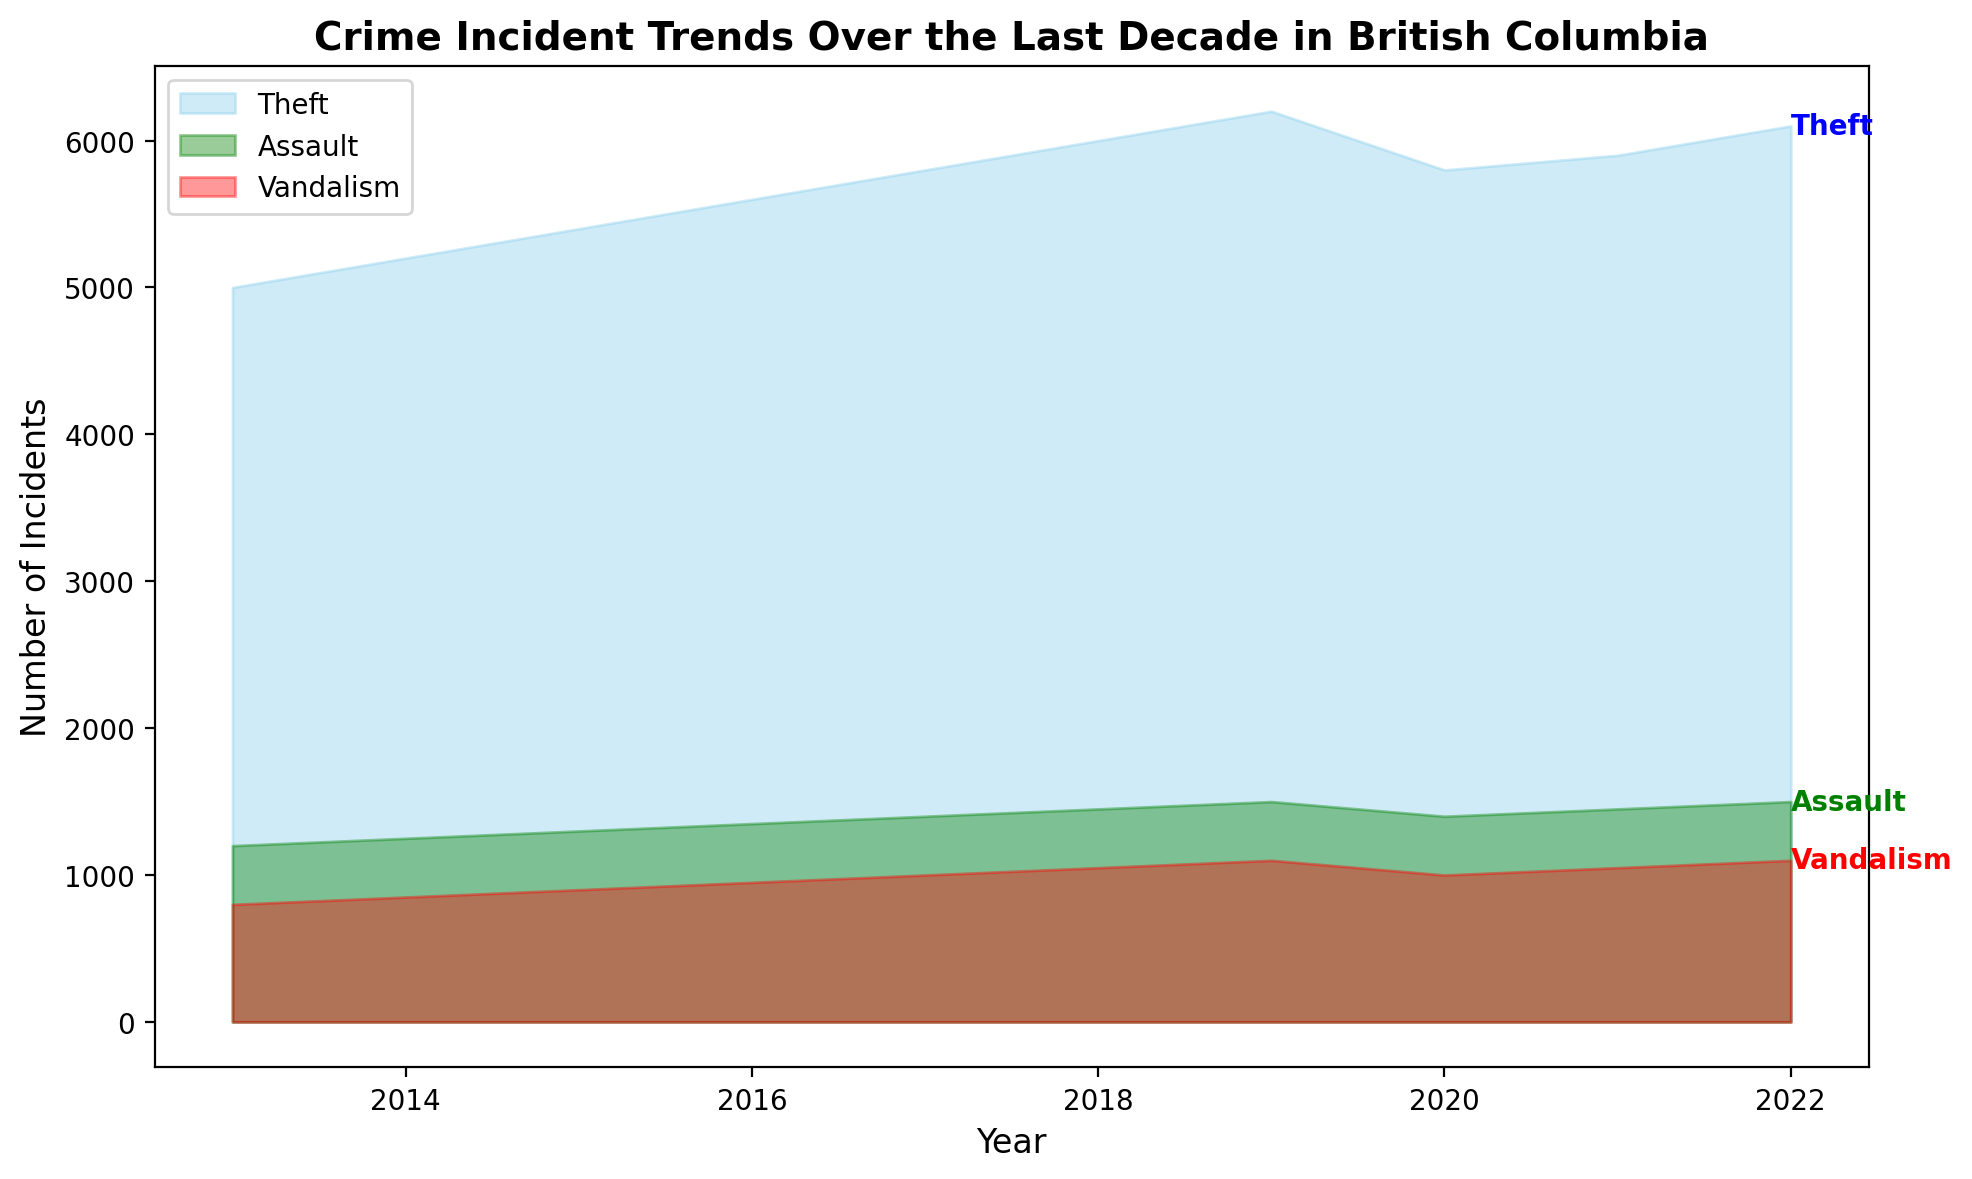How has the trend of theft incidents changed from 2013 to 2022? The trend of theft incidents has shown a general increase from 2013 to 2022, starting at 5000 incidents in 2013 and reaching 6100 in 2022 with a small dip in 2020.
Answer: Increased with a dip Which crime type had the highest number of incidents in 2016? Comparing the visual heights of the filled areas for theft, assault, and vandalism in 2016, theft had the highest number of incidents, visibly higher than the other two crime types.
Answer: Theft By how much did vandalism incidents increase from 2013 to 2019? Vandalism incidents increased from 800 in 2013 to 1100 in 2019. The difference is 1100 - 800 = 300 incidents.
Answer: 300 incidents Are there any years where the number of theft incidents decreased compared to the previous year? By reviewing the visual trend for theft, the number decreased in 2020, with incidents dropping from 6200 in 2019 to 5800 in 2020.
Answer: 2020 What is the overall trend for assault incidents over the decade? The trend for assault incidents shows a steady increase over the decade from 1200 in 2013 to 1500 in 2022, with no major drops.
Answer: Steady increase In which year did assault incidents first surpass 1400? Assault incidents first surpassed 1400 in 2018, reaching 1450 incidents.
Answer: 2018 When comparing the years 2019 and 2021, which year had higher vandalism incidents, and by how much? Vandalism incidents were higher in 2019 compared to 2021. In 2019, there were 1100 incidents, and in 2021, there were 1050. The difference is 1100 - 1050 = 50 incidents.
Answer: 2019 by 50 incidents Is there any crime type that decreased in frequency after reaching a peak within the decade? Theft incidents reached a peak in 2019 with 6200 incidents and then decreased to 5800 in 2020, before rising again.
Answer: Theft What is the cumulative increase in theft incidents from 2013 to 2018? The cumulative increase can be calculated by subtracting the number of theft incidents in 2013 from those in 2018: 6000 - 5000 = 1000 incidents.
Answer: 1000 incidents 